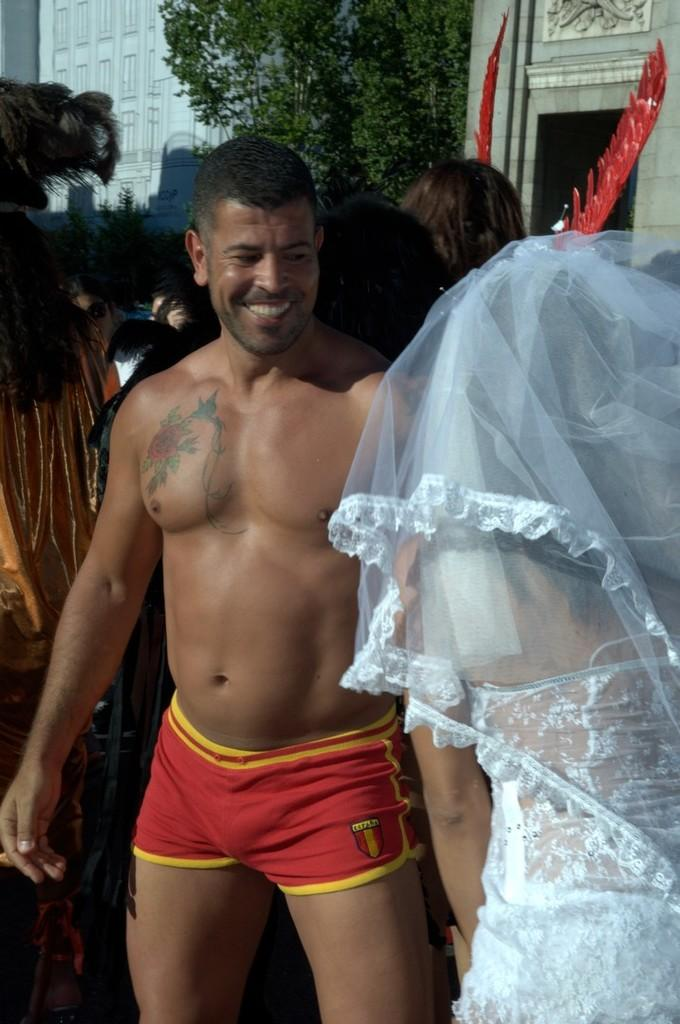What is the woman on the right side of the image wearing? The woman on the right side of the image is wearing a bridal dress. Who is standing in the center of the image? There is a person standing in the center of the image. What can be seen in the background of the image? There are trees, at least one building, and people in the background of the image. What other objects can be seen in the background of the image? There are other objects in the background of the image. What type of noise can be heard coming from the stick in the image? There is no stick present in the image, so it is not possible to determine what, if any, noise might be heard. 